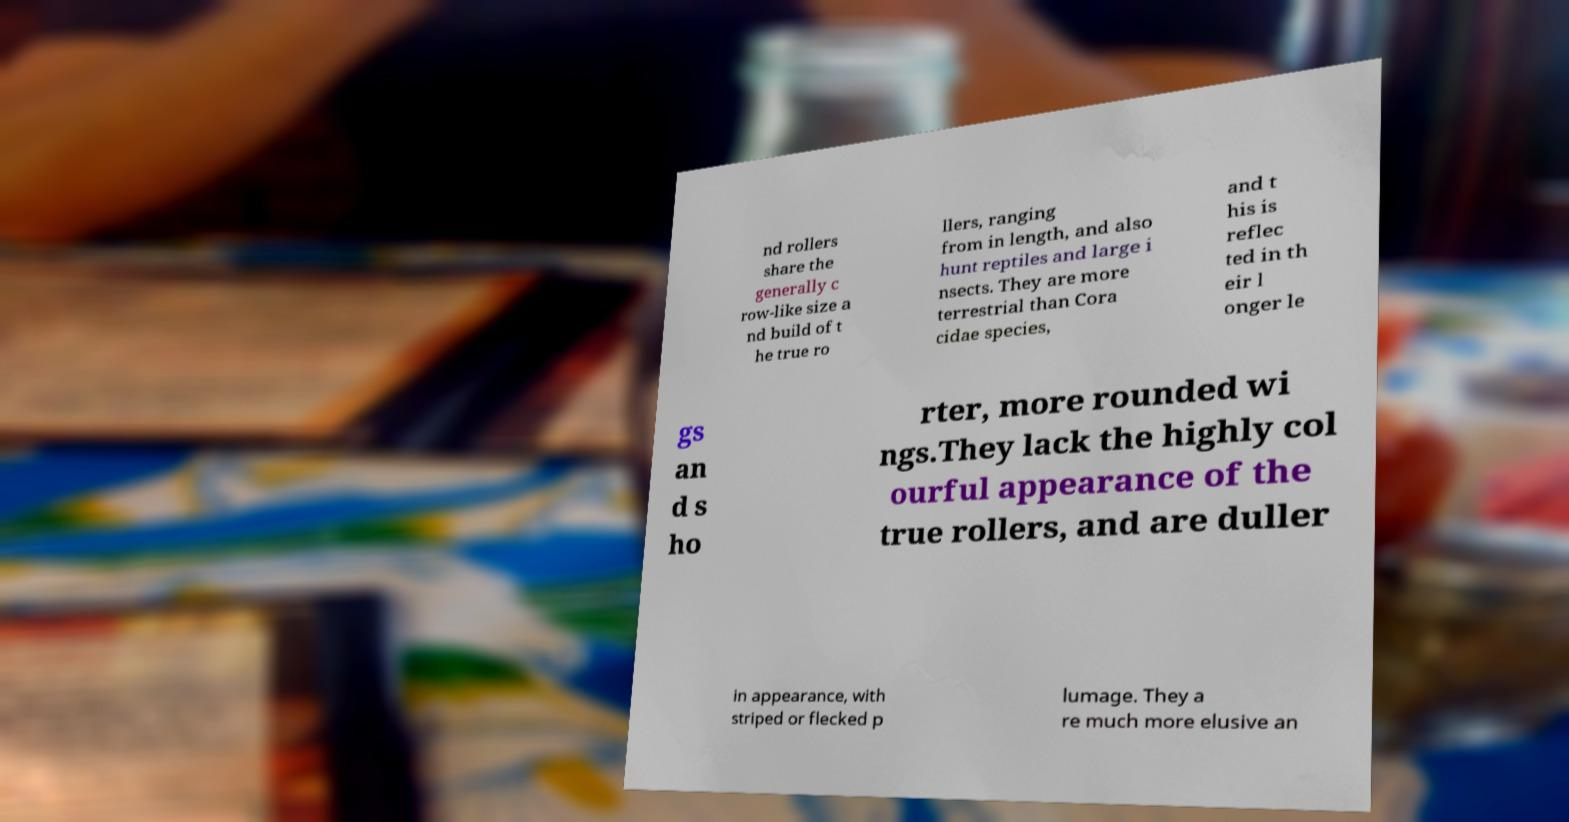For documentation purposes, I need the text within this image transcribed. Could you provide that? nd rollers share the generally c row-like size a nd build of t he true ro llers, ranging from in length, and also hunt reptiles and large i nsects. They are more terrestrial than Cora cidae species, and t his is reflec ted in th eir l onger le gs an d s ho rter, more rounded wi ngs.They lack the highly col ourful appearance of the true rollers, and are duller in appearance, with striped or flecked p lumage. They a re much more elusive an 